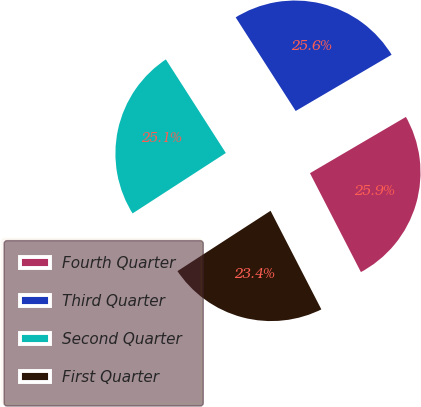Convert chart. <chart><loc_0><loc_0><loc_500><loc_500><pie_chart><fcel>Fourth Quarter<fcel>Third Quarter<fcel>Second Quarter<fcel>First Quarter<nl><fcel>25.87%<fcel>25.63%<fcel>25.08%<fcel>23.42%<nl></chart> 